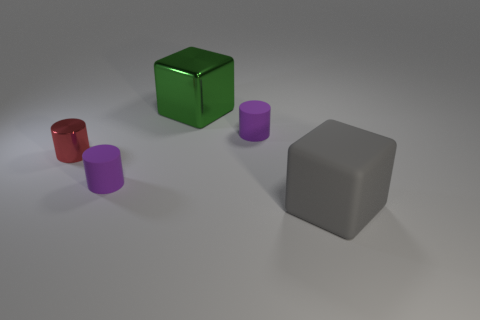What number of other objects are there of the same color as the large rubber block?
Offer a very short reply. 0. There is a green metal thing; is it the same size as the purple object in front of the tiny shiny cylinder?
Provide a short and direct response. No. Do the cube that is behind the gray object and the big gray rubber object have the same size?
Provide a short and direct response. Yes. What number of other things are there of the same material as the gray block
Offer a terse response. 2. Are there an equal number of green objects that are to the right of the big metallic thing and large cubes to the left of the gray rubber object?
Make the answer very short. No. There is a small cylinder on the right side of the purple rubber cylinder that is in front of the purple cylinder that is right of the green thing; what is its color?
Your answer should be very brief. Purple. There is a metal thing that is in front of the large metallic cube; what is its shape?
Ensure brevity in your answer.  Cylinder. There is a red object that is the same material as the green object; what shape is it?
Give a very brief answer. Cylinder. What number of small cylinders are in front of the red metal thing?
Offer a terse response. 1. Are there an equal number of small metal cylinders that are in front of the large matte thing and blue blocks?
Your response must be concise. Yes. 